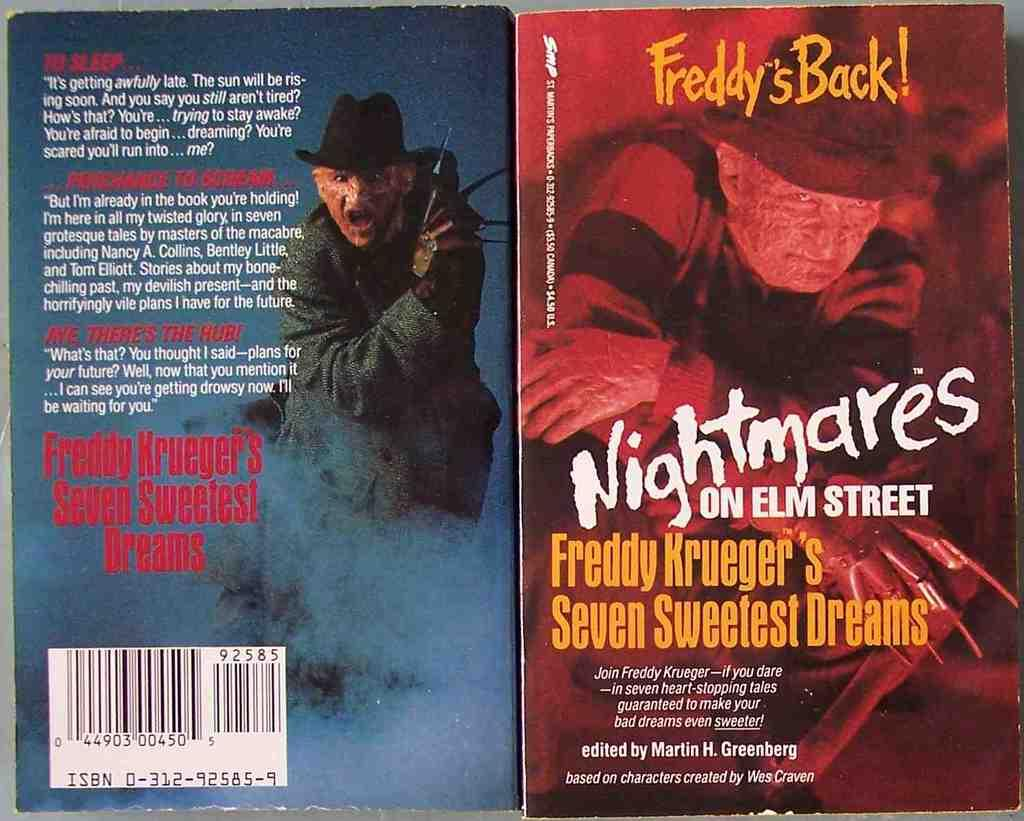<image>
Present a compact description of the photo's key features. A couple of horror paperbacks are based on the Nightmare on Elm Street movies. 